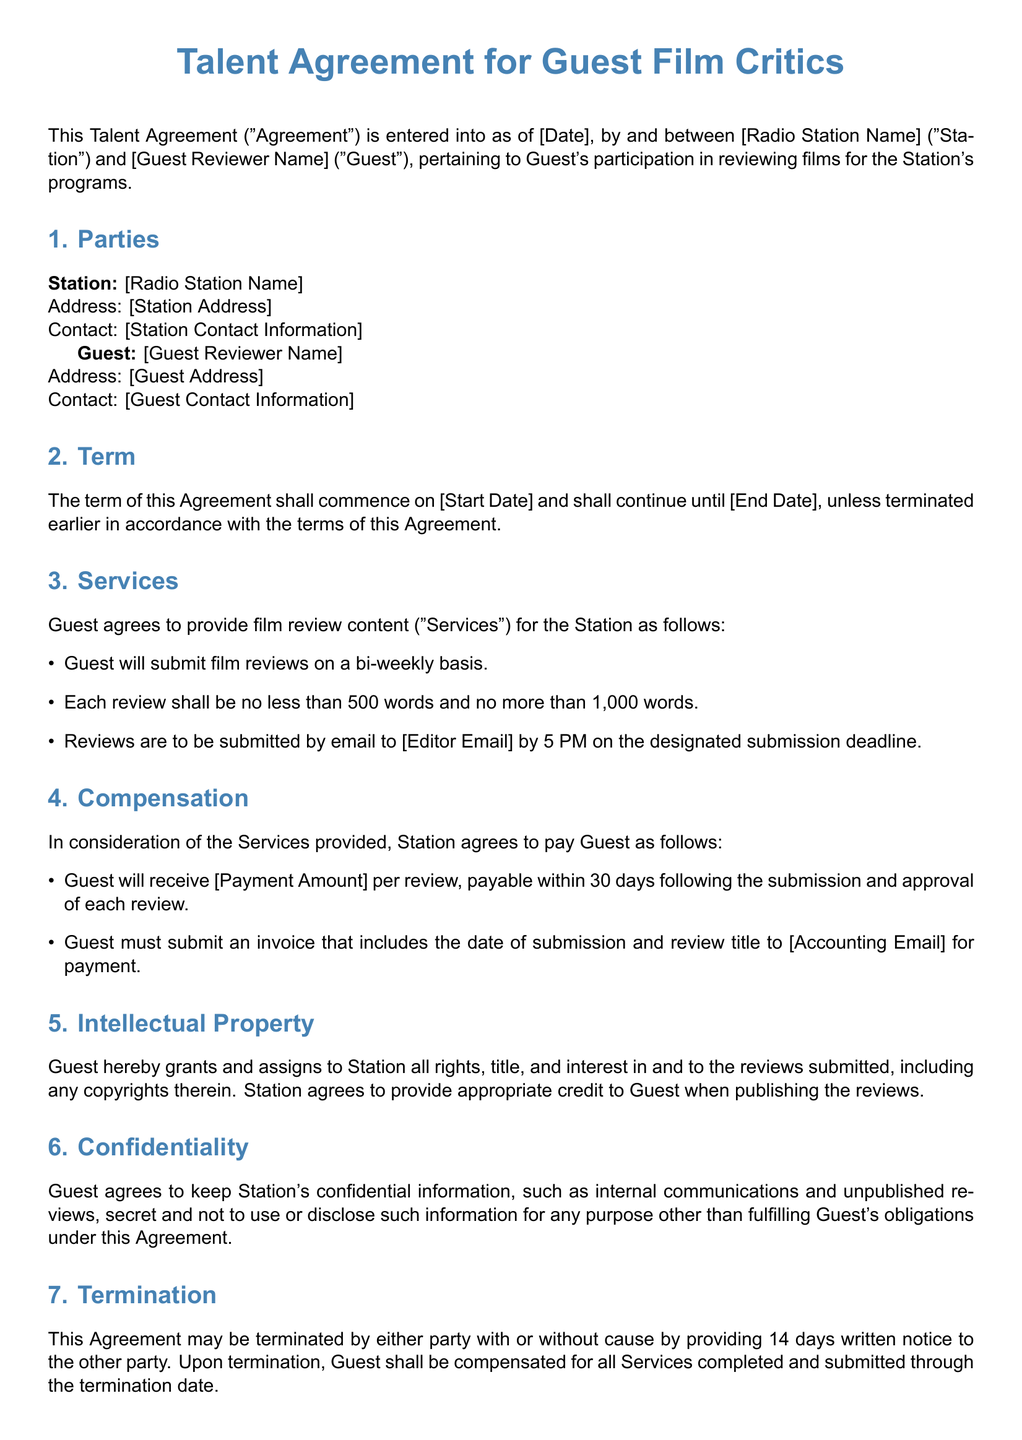What is the effective date of the Agreement? The effective date is specified as [Date] in the Agreement.
Answer: [Date] What is the bi-weekly submission requirement? The Agreement states that the Guest will submit film reviews on a bi-weekly basis.
Answer: bi-weekly What is the maximum word count for each review? The document specifies that each review must be no more than 1,000 words.
Answer: 1,000 words What is the payment amount per review? The specific amount is not provided in the document but is stated as [Payment Amount].
Answer: [Payment Amount] How many days' notice is required for termination? The Agreement indicates that 14 days' written notice is required for termination.
Answer: 14 days What should the Guest include in the invoice for payment? The Guest must include the date of submission and review title in the invoice.
Answer: date of submission and review title Who will receive credit for the published reviews? The document specifies that the Station will provide appropriate credit to the Guest.
Answer: Guest What state governs the Agreement? The governing law of the Agreement is specified as the laws of the State of [State].
Answer: [State] What is the term duration of the Agreement? The term duration is defined from [Start Date] until [End Date].
Answer: [Start Date] until [End Date] 